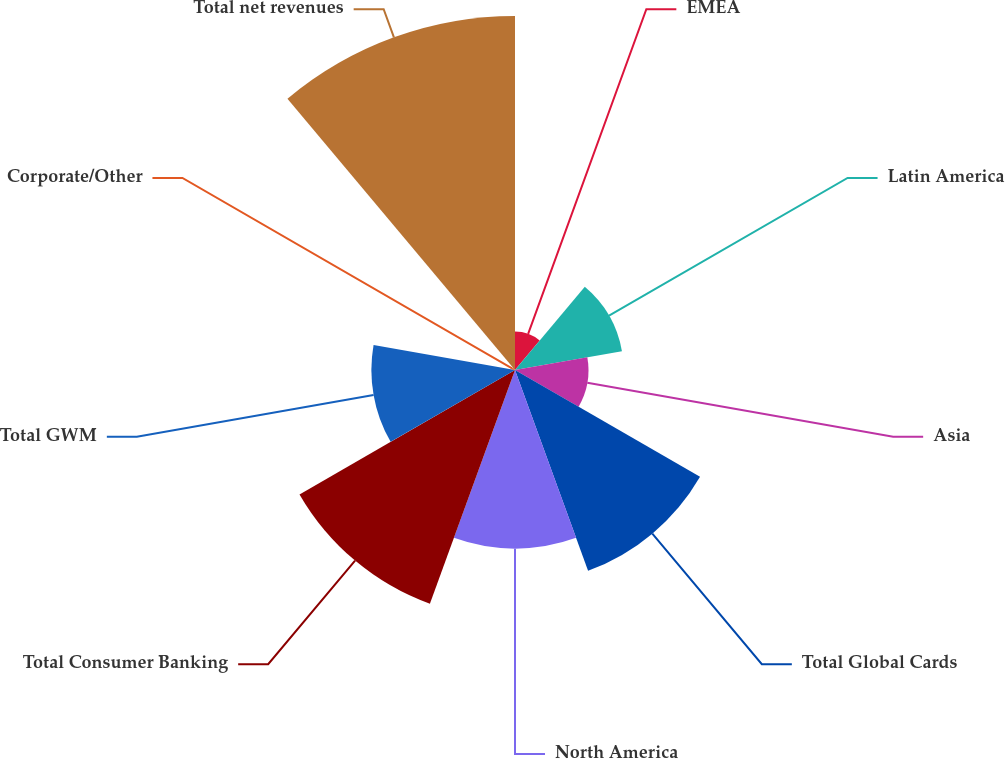Convert chart to OTSL. <chart><loc_0><loc_0><loc_500><loc_500><pie_chart><fcel>EMEA<fcel>Latin America<fcel>Asia<fcel>Total Global Cards<fcel>North America<fcel>Total Consumer Banking<fcel>Total GWM<fcel>Corporate/Other<fcel>Total net revenues<nl><fcel>2.82%<fcel>7.97%<fcel>5.39%<fcel>15.68%<fcel>13.11%<fcel>18.26%<fcel>10.54%<fcel>0.25%<fcel>25.98%<nl></chart> 